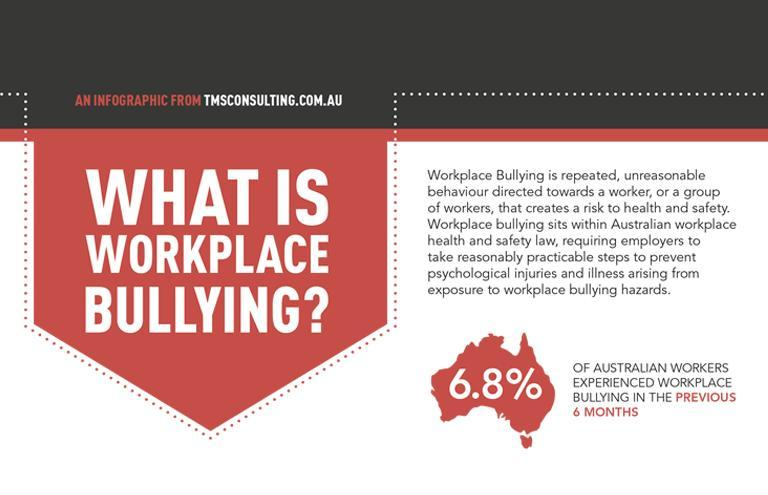what type of negative practice is being discussed here?
Answer the question with a short phrase. workplace bullying in which colour in the decimal digit shown, red or white? white 